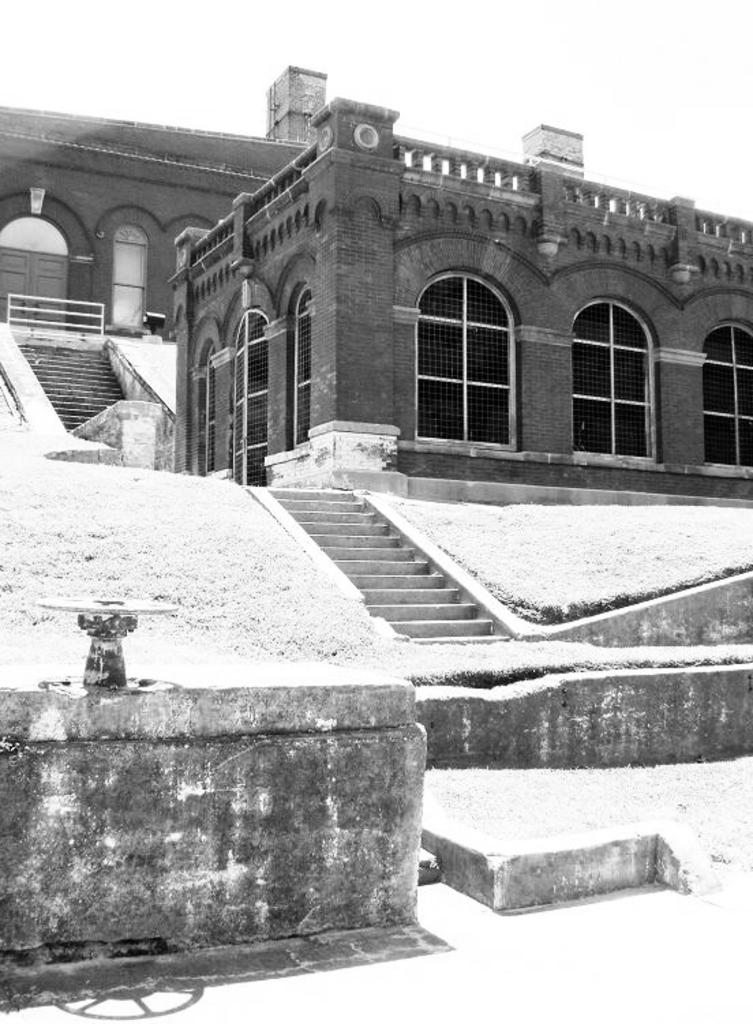What is the color scheme of the image? The image is black and white. What type of structures can be seen in the image? There are buildings in the image. Are there any architectural features present in the image? Yes, there are steps in the image. What else can be seen in the image besides the buildings and steps? There is a wall in the image. What part of the natural environment is visible in the image? The sky is visible in the image. What type of scientific error can be seen in the image? There is no scientific error present in the image; it features buildings, steps, a wall, and the sky. 